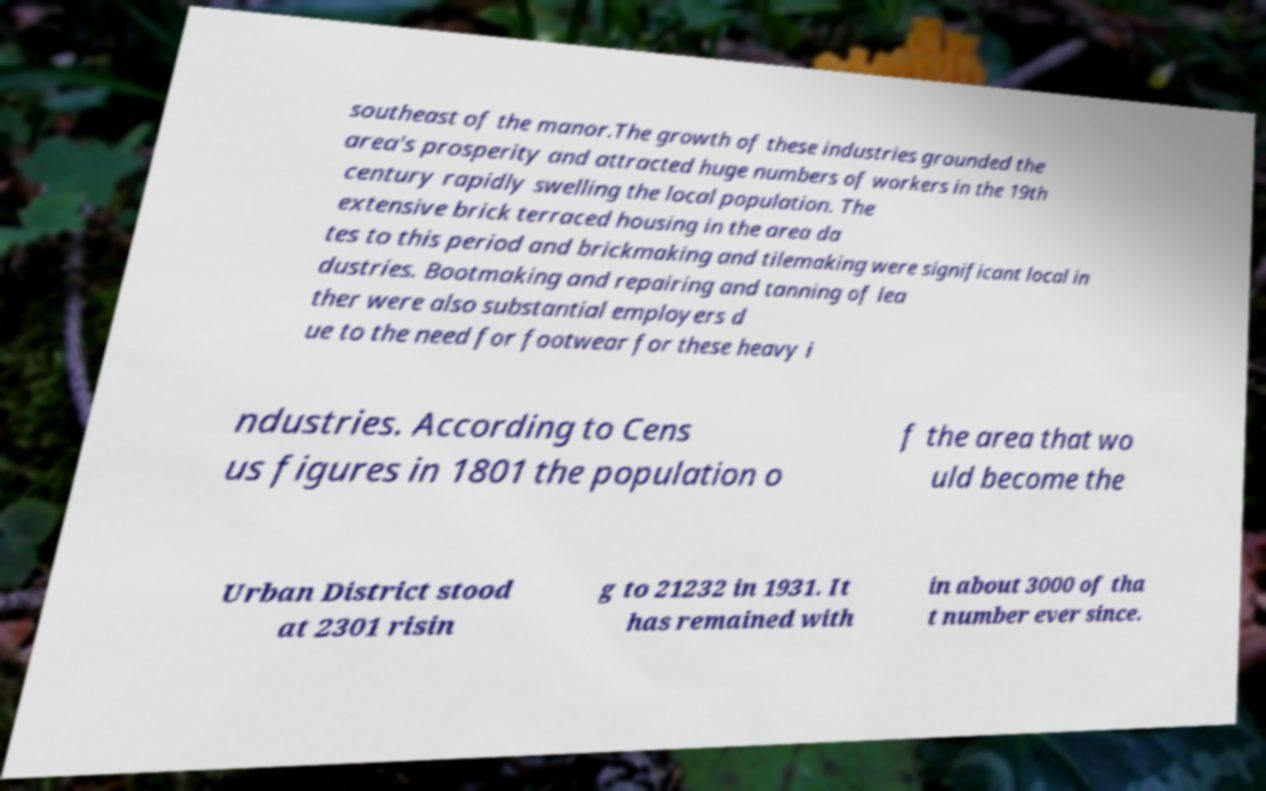Please read and relay the text visible in this image. What does it say? southeast of the manor.The growth of these industries grounded the area's prosperity and attracted huge numbers of workers in the 19th century rapidly swelling the local population. The extensive brick terraced housing in the area da tes to this period and brickmaking and tilemaking were significant local in dustries. Bootmaking and repairing and tanning of lea ther were also substantial employers d ue to the need for footwear for these heavy i ndustries. According to Cens us figures in 1801 the population o f the area that wo uld become the Urban District stood at 2301 risin g to 21232 in 1931. It has remained with in about 3000 of tha t number ever since. 